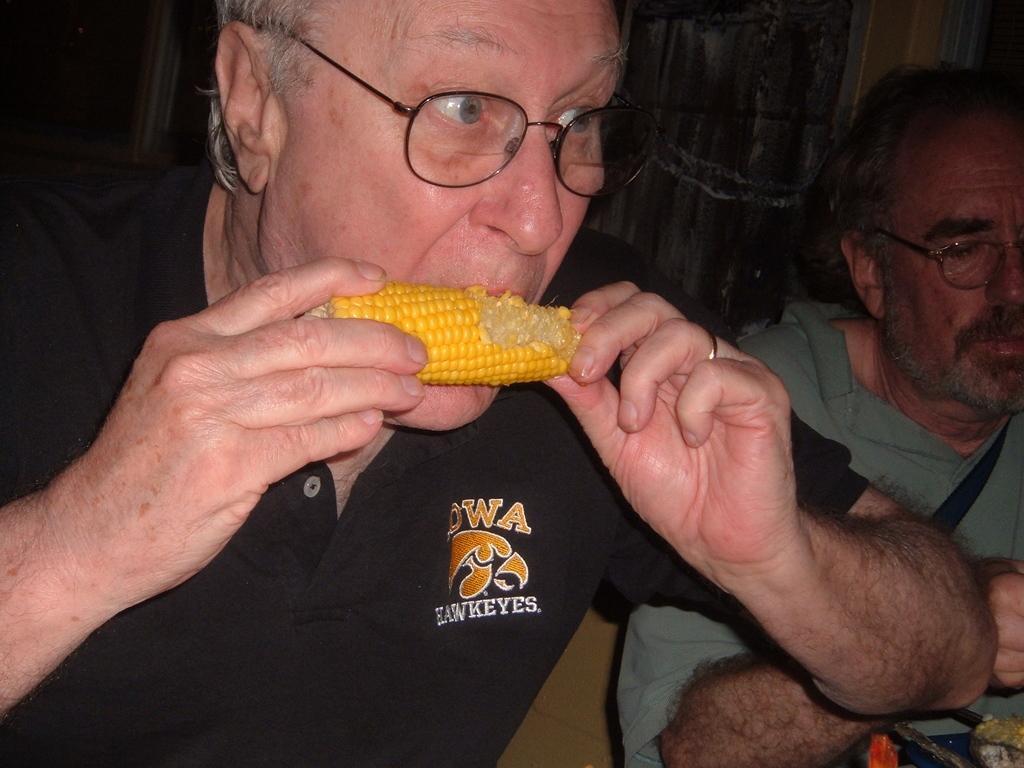Please provide a concise description of this image. This image consists of two persons. In the front, the man wearing black T-shirt is eating corn. On the right, the man is wearing a green T-shirt. 